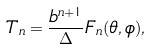Convert formula to latex. <formula><loc_0><loc_0><loc_500><loc_500>T _ { n } = \frac { b ^ { n + 1 } } { \Delta } F _ { n } ( \theta , \phi ) ,</formula> 